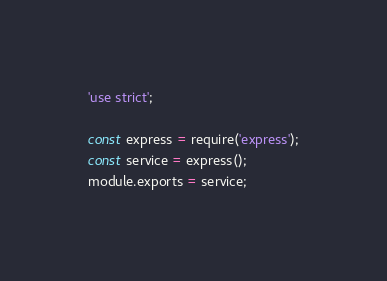<code> <loc_0><loc_0><loc_500><loc_500><_JavaScript_>'use strict';

const express = require('express');
const service = express();
module.exports = service;</code> 